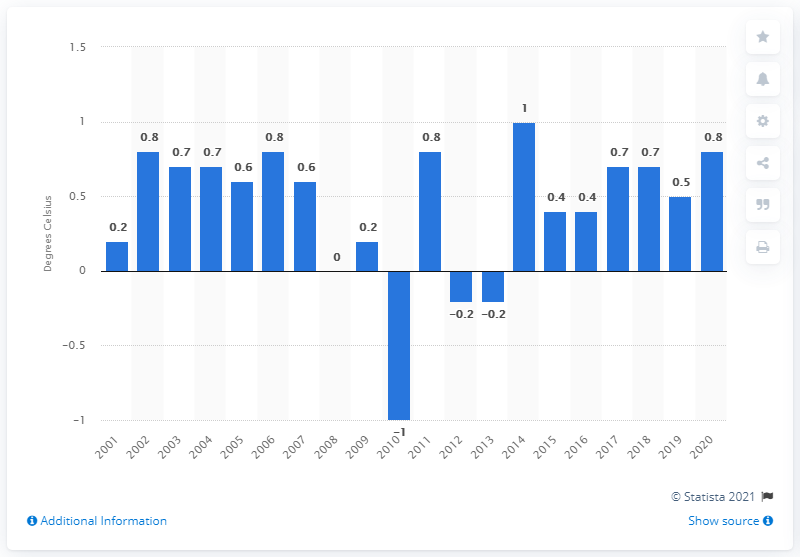Specify some key components in this picture. In 2014, the deviation of the mean annual temperature in the UK fell below one degree Celsius, indicating a significant change in the national temperature trend. 